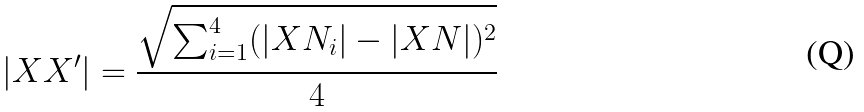Convert formula to latex. <formula><loc_0><loc_0><loc_500><loc_500>| X X ^ { \prime } | = \frac { \sqrt { \sum _ { i = 1 } ^ { 4 } ( | X N _ { i } | - | X N | ) ^ { 2 } } } { 4 }</formula> 